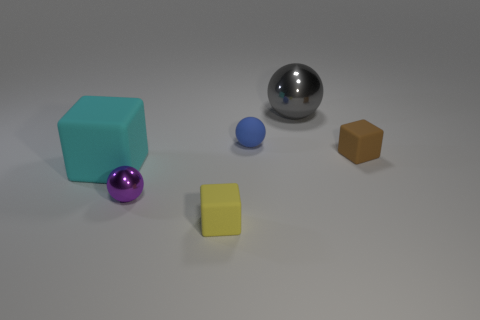Are there fewer red matte things than small balls?
Ensure brevity in your answer.  Yes. The rubber cube that is behind the small yellow object and to the left of the brown block is what color?
Your answer should be compact. Cyan. There is a small yellow thing that is the same shape as the tiny brown matte object; what is it made of?
Your answer should be compact. Rubber. Is there any other thing that has the same size as the cyan block?
Ensure brevity in your answer.  Yes. Are there more small yellow blocks than tiny green shiny blocks?
Keep it short and to the point. Yes. What is the size of the block that is both behind the yellow matte thing and left of the tiny brown cube?
Offer a very short reply. Large. The big cyan thing has what shape?
Keep it short and to the point. Cube. What number of other tiny things have the same shape as the tiny brown object?
Your answer should be compact. 1. Are there fewer large cyan rubber objects that are behind the purple sphere than metal things that are behind the blue thing?
Give a very brief answer. No. There is a tiny rubber object in front of the purple metal sphere; what number of cyan blocks are in front of it?
Provide a succinct answer. 0. 